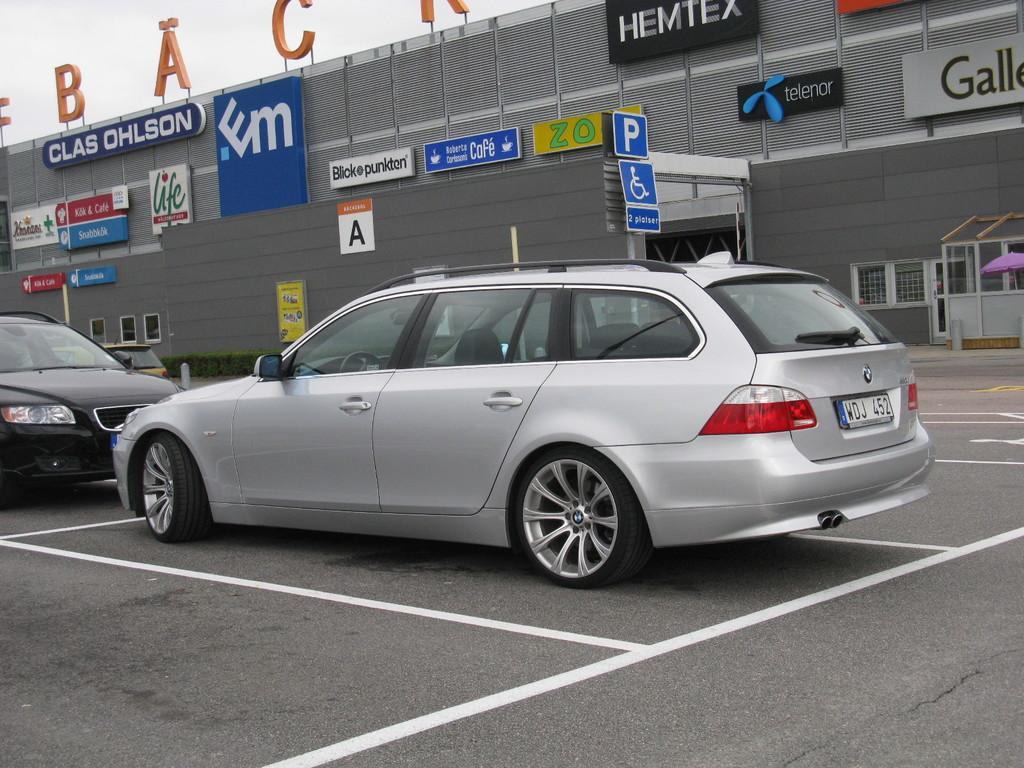<image>
Create a compact narrative representing the image presented. Cars parked outside a building which says "CLAS OHLSON" on it. 